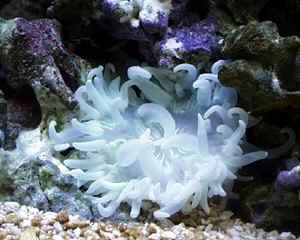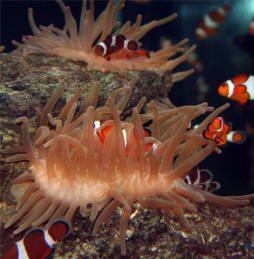The first image is the image on the left, the second image is the image on the right. For the images shown, is this caption "Right image features an anemone with stringy whitish tendrils, and the left image includes a pale white anemone." true? Answer yes or no. No. The first image is the image on the left, the second image is the image on the right. Given the left and right images, does the statement "There are at least two clown fish." hold true? Answer yes or no. Yes. 